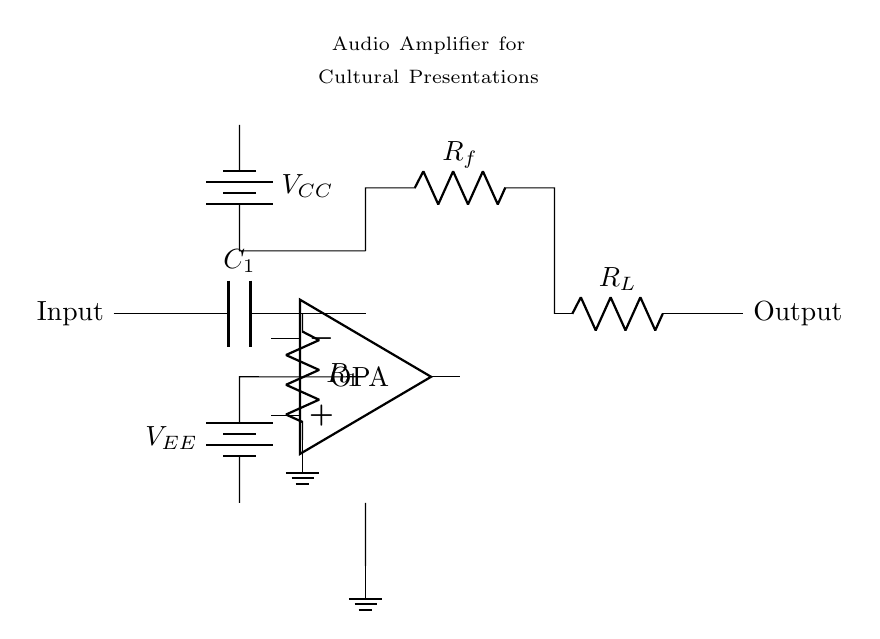What component is used to couple the input signal? The circuit uses a capacitor denoted as C1 to couple the input signal to the rest of the amplifier. Capacitors are typically used to block DC while allowing AC signals to pass.
Answer: Capacitor What is the purpose of the resistor labeled R1? R1 is used as a load resistor for the operational amplifier (OPA), helping to set the gain and stabilize the amplifier's operation. This resistor is critical for controlling the output characteristics.
Answer: Load resistor How many power supplies are shown in the circuit? There are two power supplies indicated in the circuit: one labeled VCC for positive voltage and another labeled VEE for negative voltage, which are necessary for powering the operational amplifier.
Answer: Two What is the label of the load resistor in the output stage? The load resistor in the output stage is labeled R_L. It typically connects to the output of the amplifier, serving to provide a load for the amplifier's output stage and affect the overall circuit performance.
Answer: R_L How does this circuit improve sound quality? The circuit amplifies audio signals, allowing for clearer sound at higher volumes during cultural presentations. By boosting the signal strength, it ensures that the output is strong enough to drive speakers effectively.
Answer: By amplifying audio signals What type of circuit is represented by this diagram? The diagram represents an audio amplifier circuit. Such circuits are specifically designed to enhance signal strength, improving overall sound quality during presentations.
Answer: Audio amplifier circuit What is shown at the output of the circuit? The output of the circuit is indicated simply as "Output," representing the amplified audio signal sent to speakers or an audio system. This is where the final amplified signal can be accessed for use.
Answer: Output 